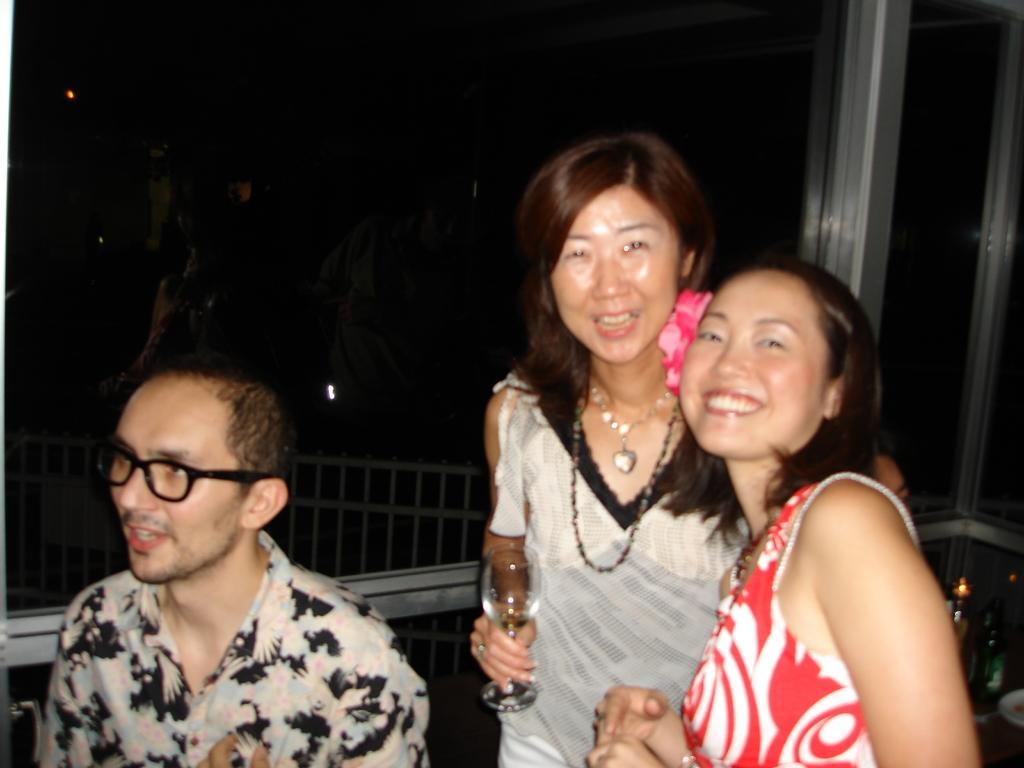Describe this image in one or two sentences. In this image we can see three people, a woman is holding a glass and there is a fence and metal rods in the background. 